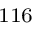<formula> <loc_0><loc_0><loc_500><loc_500>^ { 1 1 6 }</formula> 